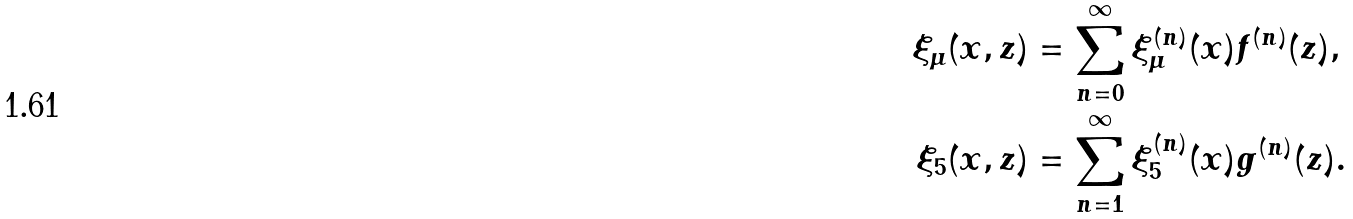Convert formula to latex. <formula><loc_0><loc_0><loc_500><loc_500>\xi _ { \mu } ( x , z ) & = \sum _ { n = 0 } ^ { \infty } \xi _ { \mu } ^ { ( n ) } ( x ) f ^ { ( n ) } ( z ) , \\ \xi _ { 5 } ( x , z ) & = \sum _ { n = 1 } ^ { \infty } \xi _ { 5 } ^ { ( n ) } ( x ) g ^ { ( n ) } ( z ) .</formula> 